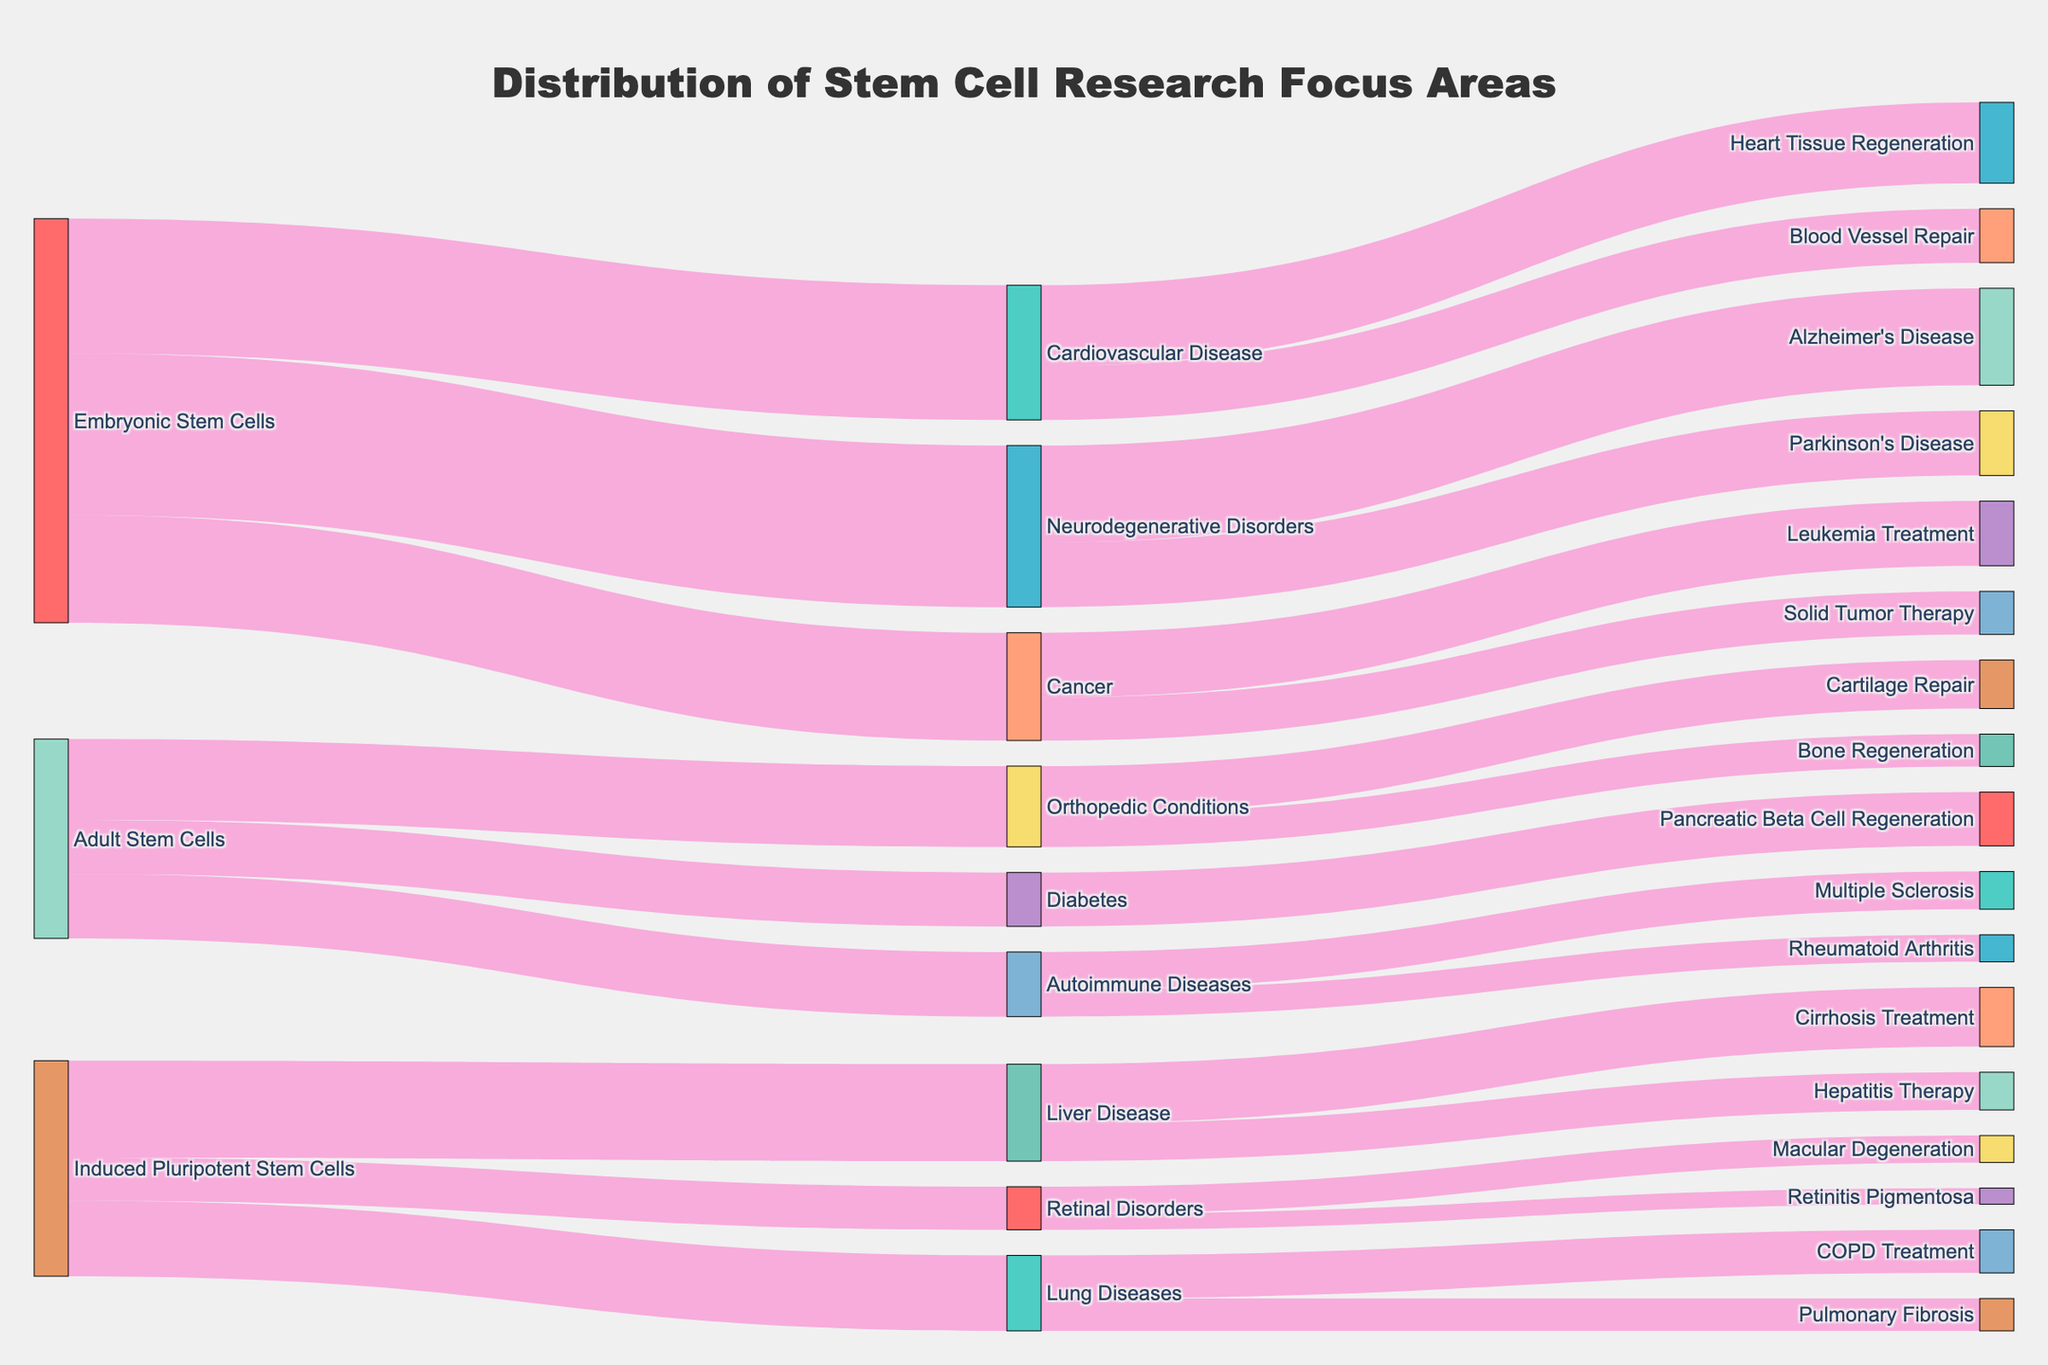What's the title of the figure? The title is displayed prominently at the top center of the figure. Looking at it, we can see it says "Distribution of Stem Cell Research Focus Areas".
Answer: Distribution of Stem Cell Research Focus Areas How many focus areas are there for Embryonic Stem Cells? By following the flow from Embryonic Stem Cells in the Sankey diagram, you can identify the different focus areas: Cardiovascular Disease, Neurodegenerative Disorders, and Cancer. Counting these tells us there are 3 focus areas.
Answer: 3 Which disease has the highest research focus from Embryonic Stem Cells? By comparing the values associated with each target node flowing from Embryonic Stem Cells, we observe that Neurodegenerative Disorders has the highest value of 30.
Answer: Neurodegenerative Disorders What is the combined research focus value for all target nodes connected to Induced Pluripotent Stem Cells? To find the combined value, sum the values of Liver Disease (18), Retinal Disorders (8), and Lung Diseases (14). This results in 18 + 8 + 14 = 40.
Answer: 40 Which specific treatment area within Cancer has the lower research focus value? By observing the flows from Cancer, you can see two target nodes: Leukemia Treatment and Solid Tumor Therapy. Comparing their values (12 for Leukemia Treatment and 8 for Solid Tumor Therapy) shows that Solid Tumor Therapy has the lower value.
Answer: Solid Tumor Therapy Is there more research focus on Autoimmune Diseases or Liver Disease? By looking at the connections from Adult Stem Cells to Autoimmune Diseases and from Induced Pluripotent Stem Cells to Liver Disease, we see values of 12 for Autoimmune Diseases and 18 for Liver Disease. Thus, Liver Disease has a higher research focus.
Answer: Liver Disease Which type of stem cell is involved in research on Retinal Disorders? Following the flow in the Sankey diagram from Retinal Disorders back to the source, we see that it only connects to Induced Pluripotent Stem Cells.
Answer: Induced Pluripotent Stem Cells What's the total research focus value directed at Diabetes-related targets? Since Diabetes only has one target node, Pancreatic Beta Cell Regeneration, the total research focus value is directly equal to its value, which is 10.
Answer: 10 